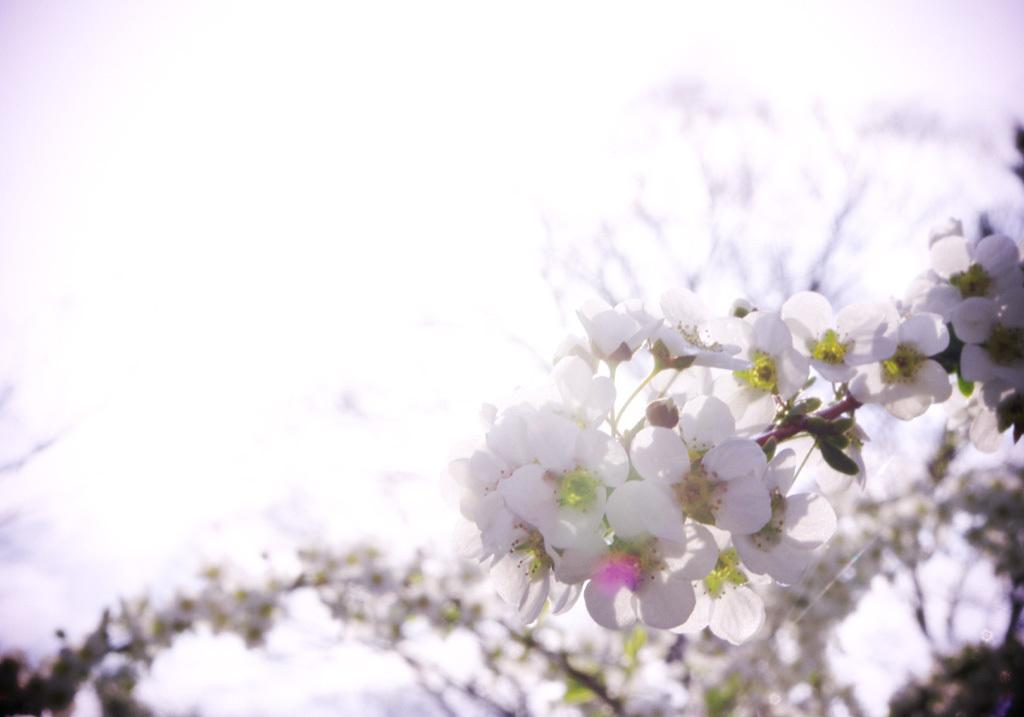What can be seen on the plants in the image? There are flowers and buds on the plants in the image. How would you describe the background of the image? The background of the image is blurred. How many feet of lead wire are connected to the bulb in the image? There is no bulb or lead wire present in the image; it features plants with flowers and buds. 